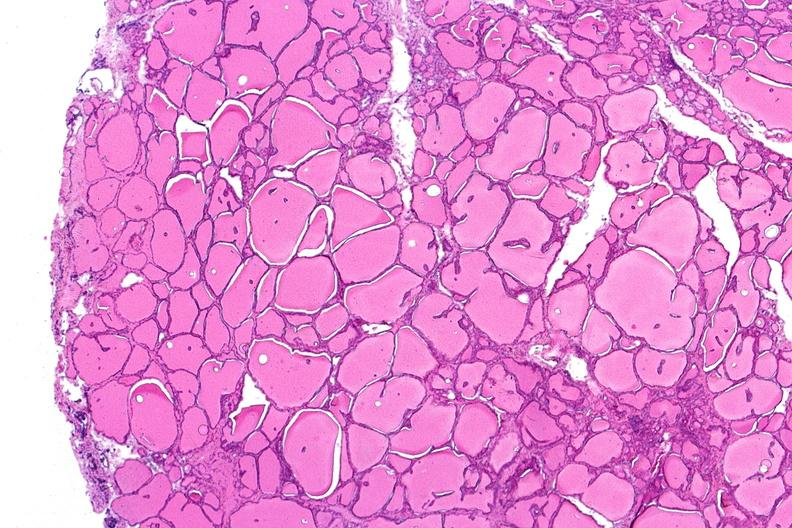does this image show thyroid, normal?
Answer the question using a single word or phrase. Yes 